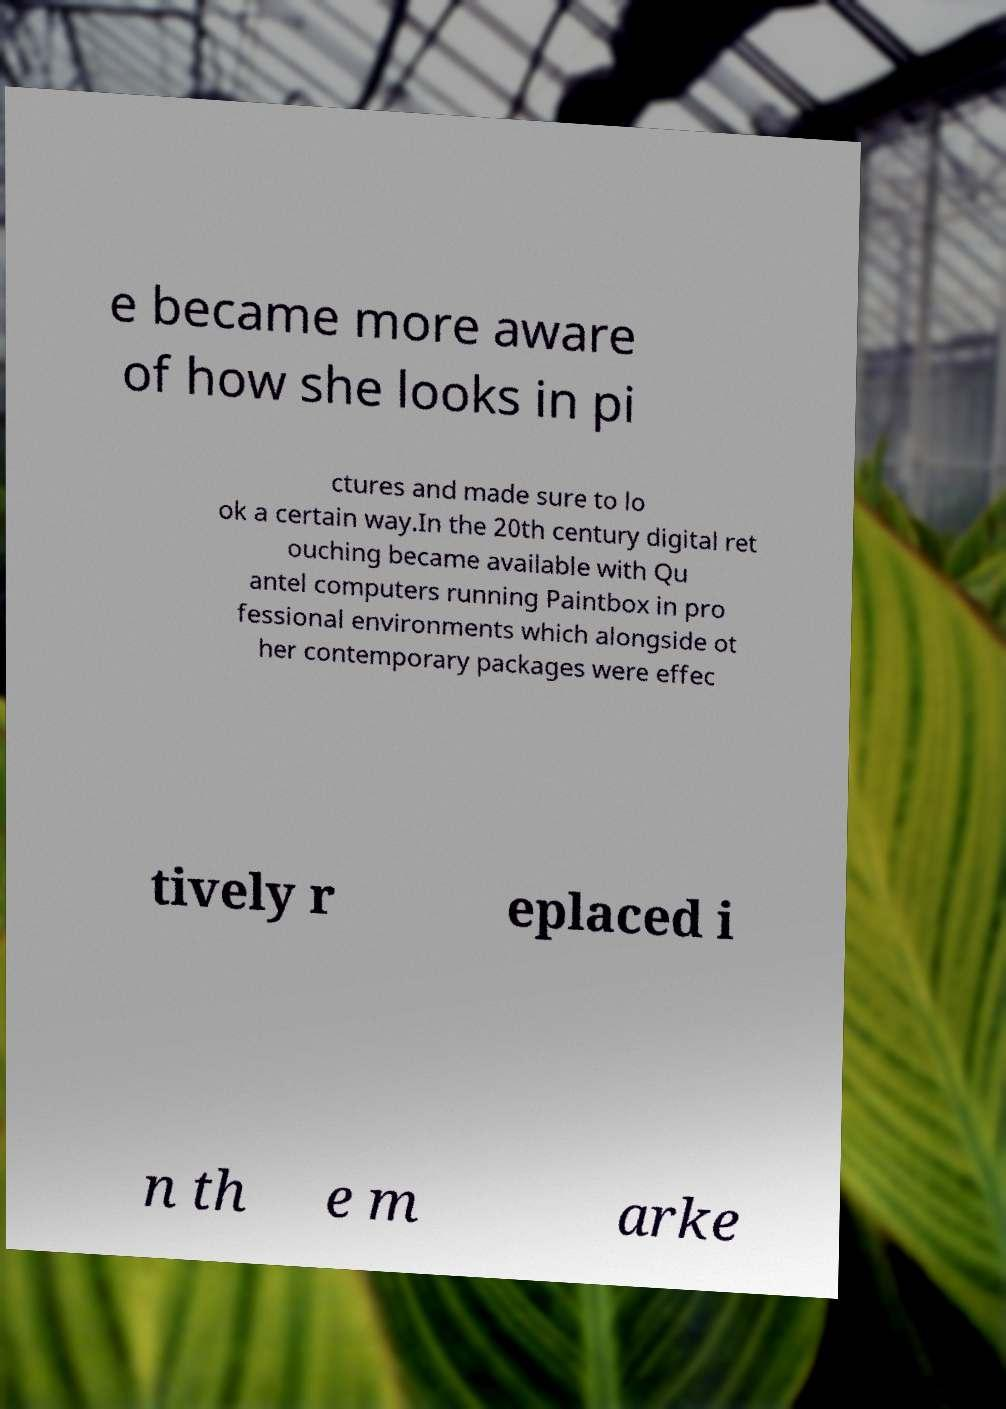Can you accurately transcribe the text from the provided image for me? e became more aware of how she looks in pi ctures and made sure to lo ok a certain way.In the 20th century digital ret ouching became available with Qu antel computers running Paintbox in pro fessional environments which alongside ot her contemporary packages were effec tively r eplaced i n th e m arke 